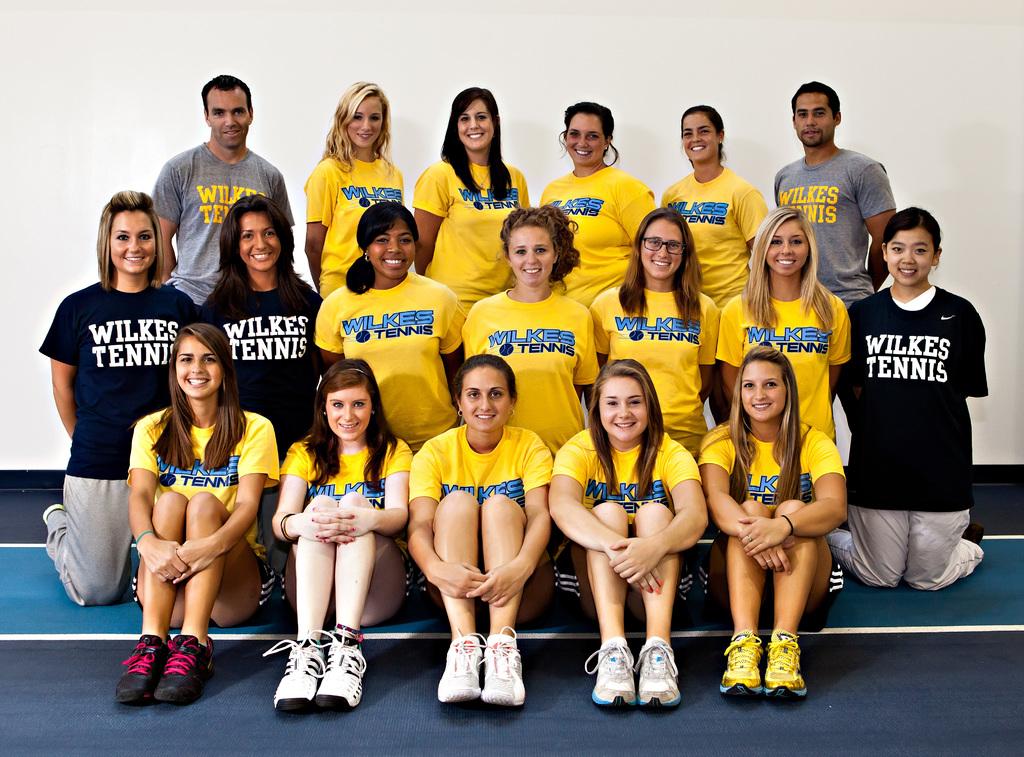What tennis team is on the shirts?
Give a very brief answer. Wilkes tennis. 